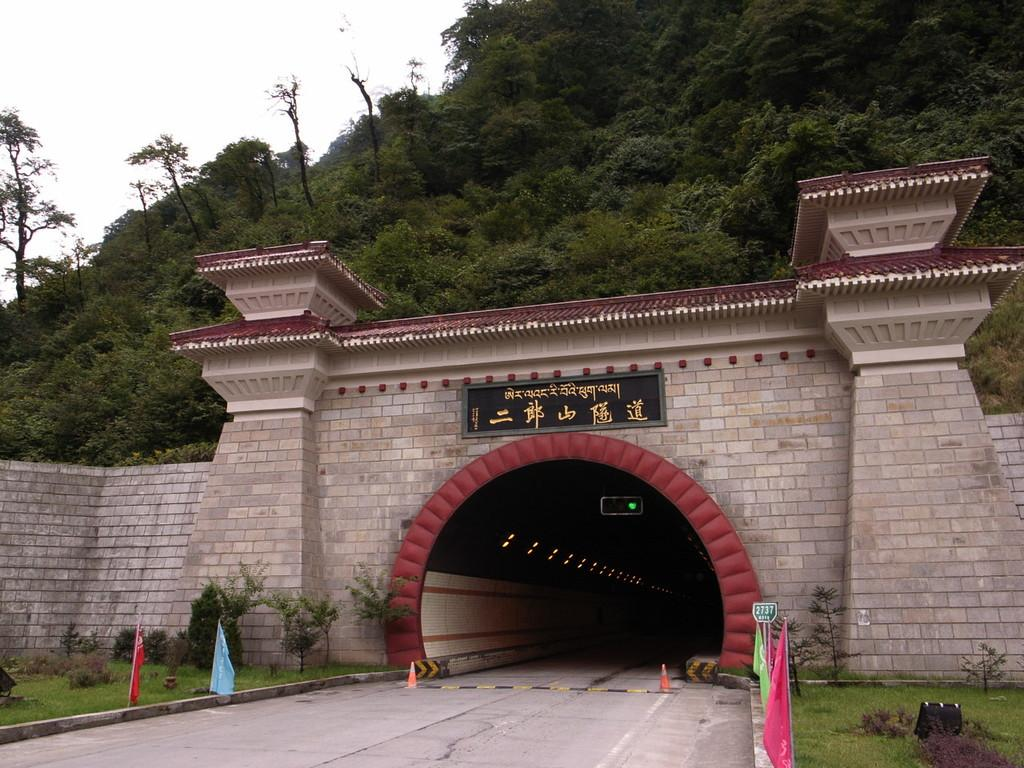What type of structure is visible in the image? There is a brick wall in the image. What natural feature can be seen in the image? There is a hill with trees in the image. How many spiders are crawling on the judge in the image? There is no judge or spiders present in the image. What color is the balloon tied to the tree on the hill? There is no balloon present in the image. 